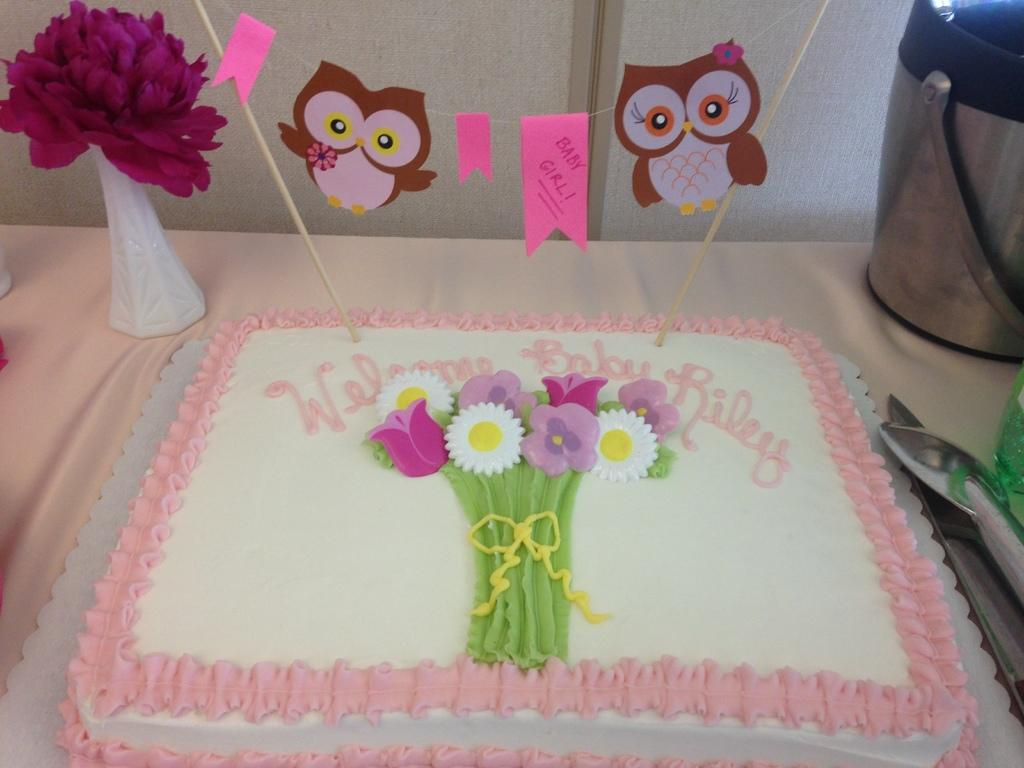What type of dessert is visible in the image? There is a white color cake in the image. Where is the cake placed? The cake is placed on a table. What other decorative item can be seen in the image? There is a purple color flower pot and a decorative hanging bird in the image. What color is the wall in the background of the image? There is a white color wall in the background of the image. How many clovers are visible on the cake in the image? There are no clovers present in the image; it features a white color cake, a table, a purple color flower pot, a decorative hanging bird, and a white color wall in the background. 